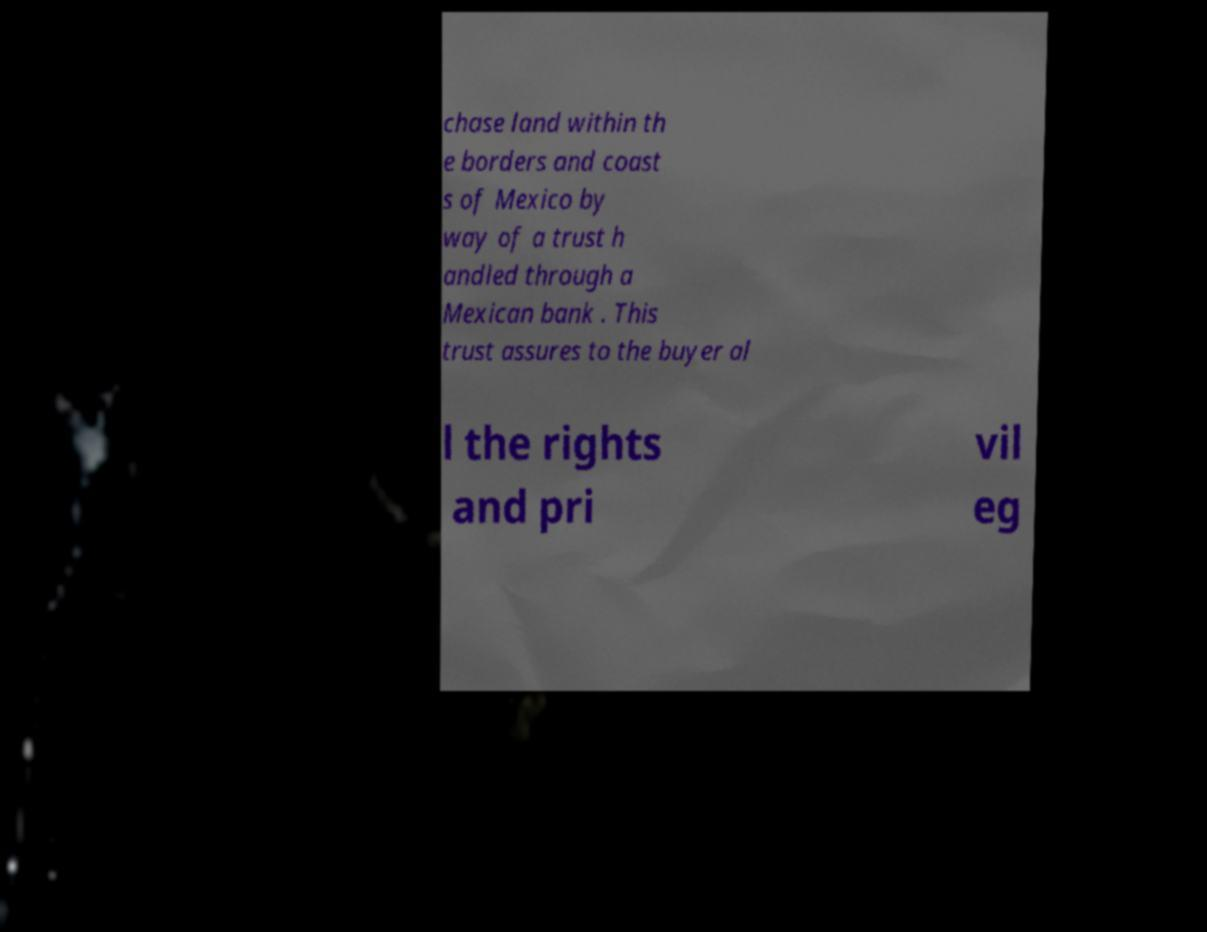What messages or text are displayed in this image? I need them in a readable, typed format. chase land within th e borders and coast s of Mexico by way of a trust h andled through a Mexican bank . This trust assures to the buyer al l the rights and pri vil eg 